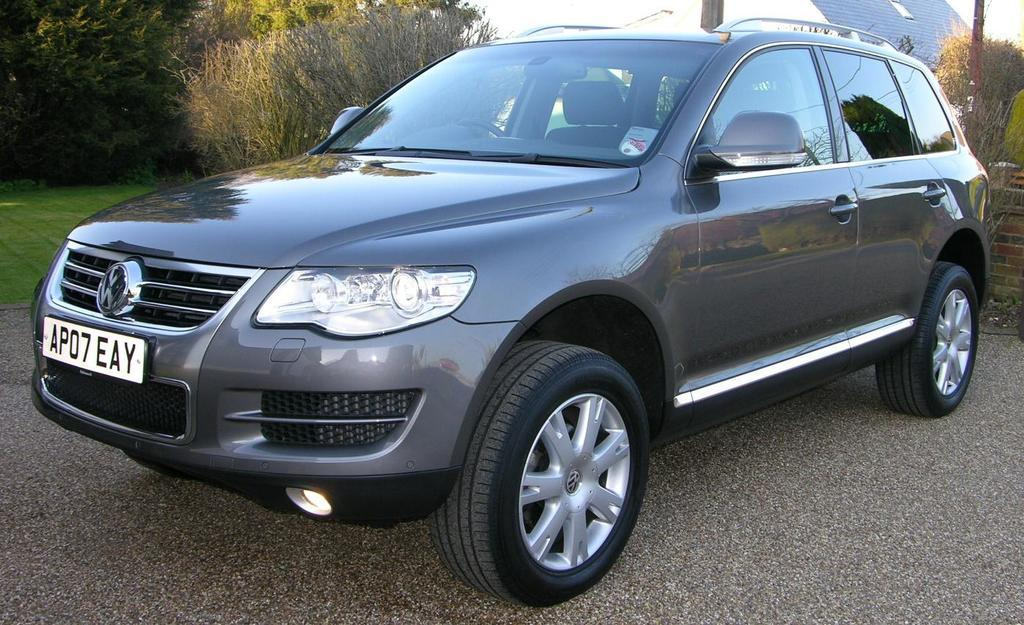What type of vehicle is in the image? There is a grey car in the image. Where is the car located? The car is on the road. What can be seen on the left side of the image? There are trees on the left side of the image. Can you hear the car bursting into laughter in the image? There is no sound in the image, and cars do not have the ability to laugh, so this cannot be observed. 